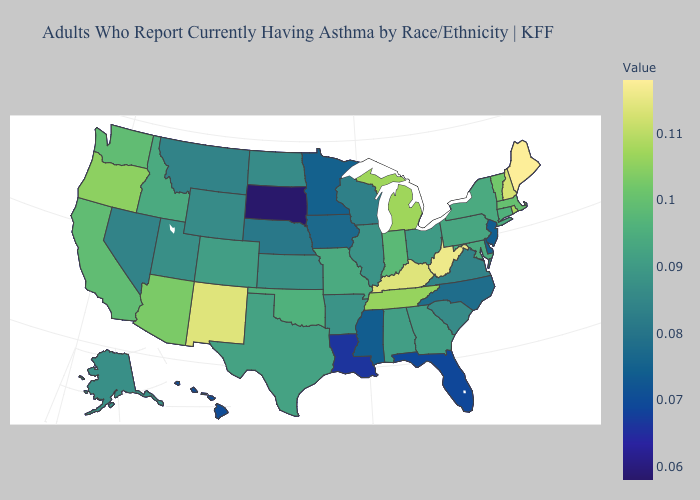Which states hav the highest value in the South?
Quick response, please. West Virginia. Does Colorado have a lower value than Minnesota?
Quick response, please. No. Among the states that border Maine , which have the lowest value?
Keep it brief. New Hampshire. Which states have the highest value in the USA?
Answer briefly. Maine. Does Kentucky have the highest value in the South?
Be succinct. No. Is the legend a continuous bar?
Keep it brief. Yes. 